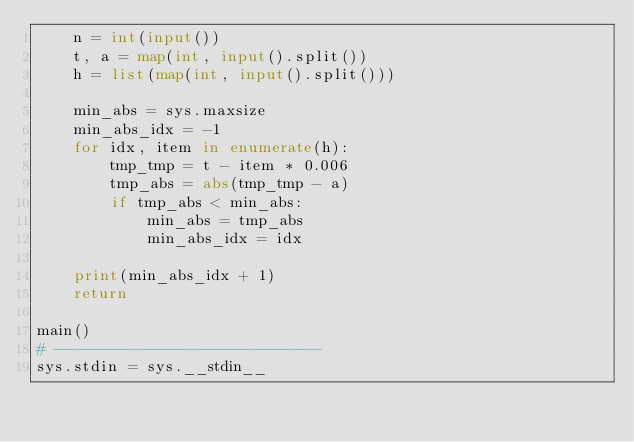<code> <loc_0><loc_0><loc_500><loc_500><_Python_>    n = int(input())
    t, a = map(int, input().split())
    h = list(map(int, input().split()))

    min_abs = sys.maxsize
    min_abs_idx = -1
    for idx, item in enumerate(h):
        tmp_tmp = t - item * 0.006
        tmp_abs = abs(tmp_tmp - a)
        if tmp_abs < min_abs:
            min_abs = tmp_abs
            min_abs_idx = idx

    print(min_abs_idx + 1)
    return

main()
# -----------------------------
sys.stdin = sys.__stdin__
</code> 